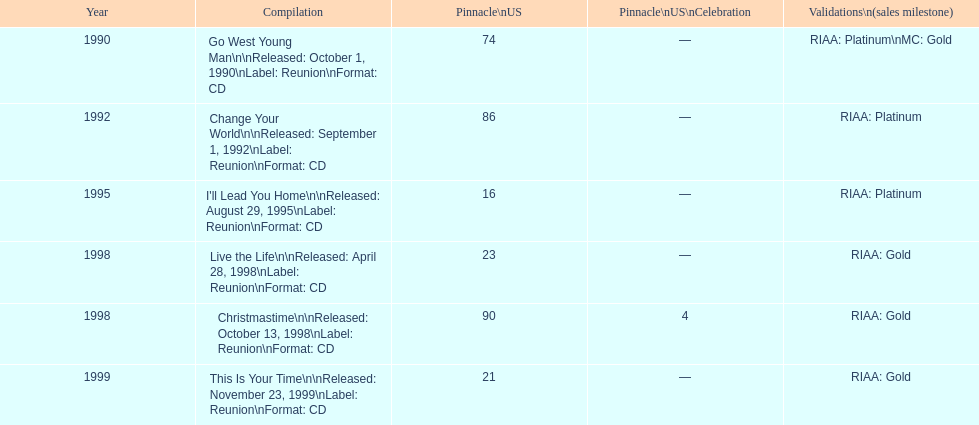How many songs are listed from 1998? 2. 